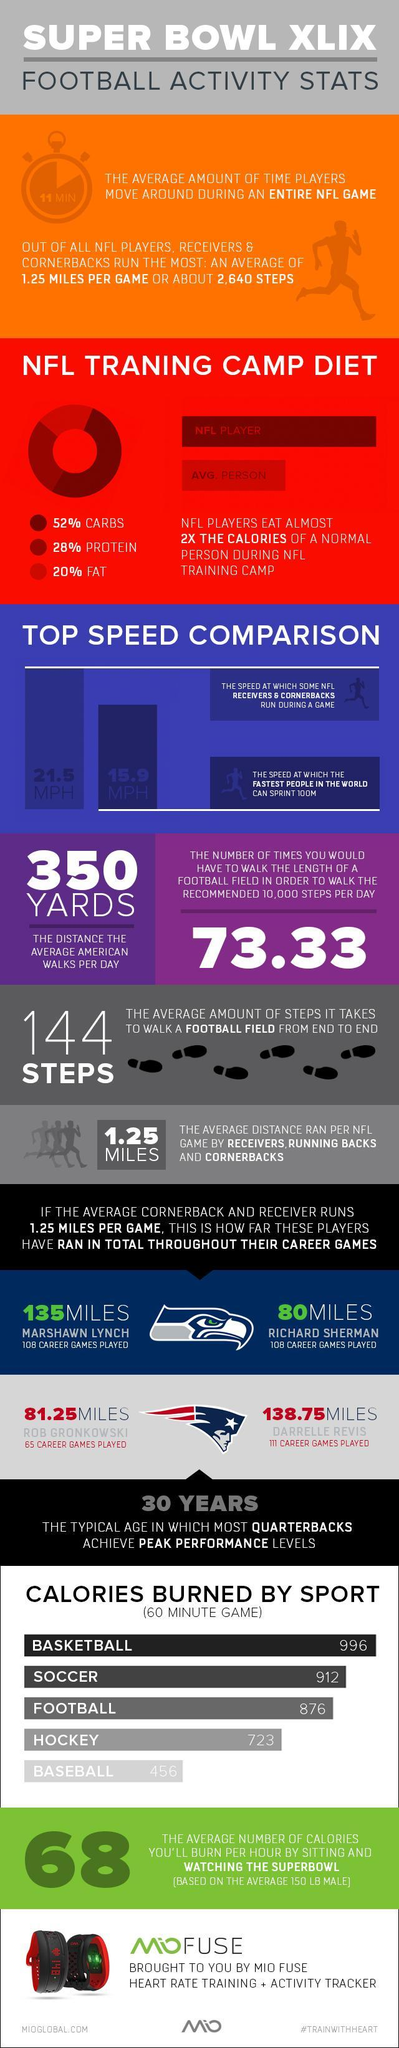What is the total time duration of a hockey game?
Answer the question with a short phrase. 60 MINUTE Which NFL team does Marshawn Lynch played for - Green Bay Packers, Seattle Seahawks, Kansas City Chiefs, Dallas Cowboys? Seattle Seahawks What is the distance an average American walks per day? 350 YARDS What is the speed at which some NFL receivers & cornerbacks run during a game? 21.5 MPH How many miles were covered by Darrelle Revis in his career? 138.75MILES How many games were played by Richard Sherman in his career? 108 What is the speed at which the fastest people in the world can sprint 100m? 15.9 MPH What percent of protein is recommended for NFL players in the NFL training camp diet? 28% How many calories per hour can be burned by playing football? 876 